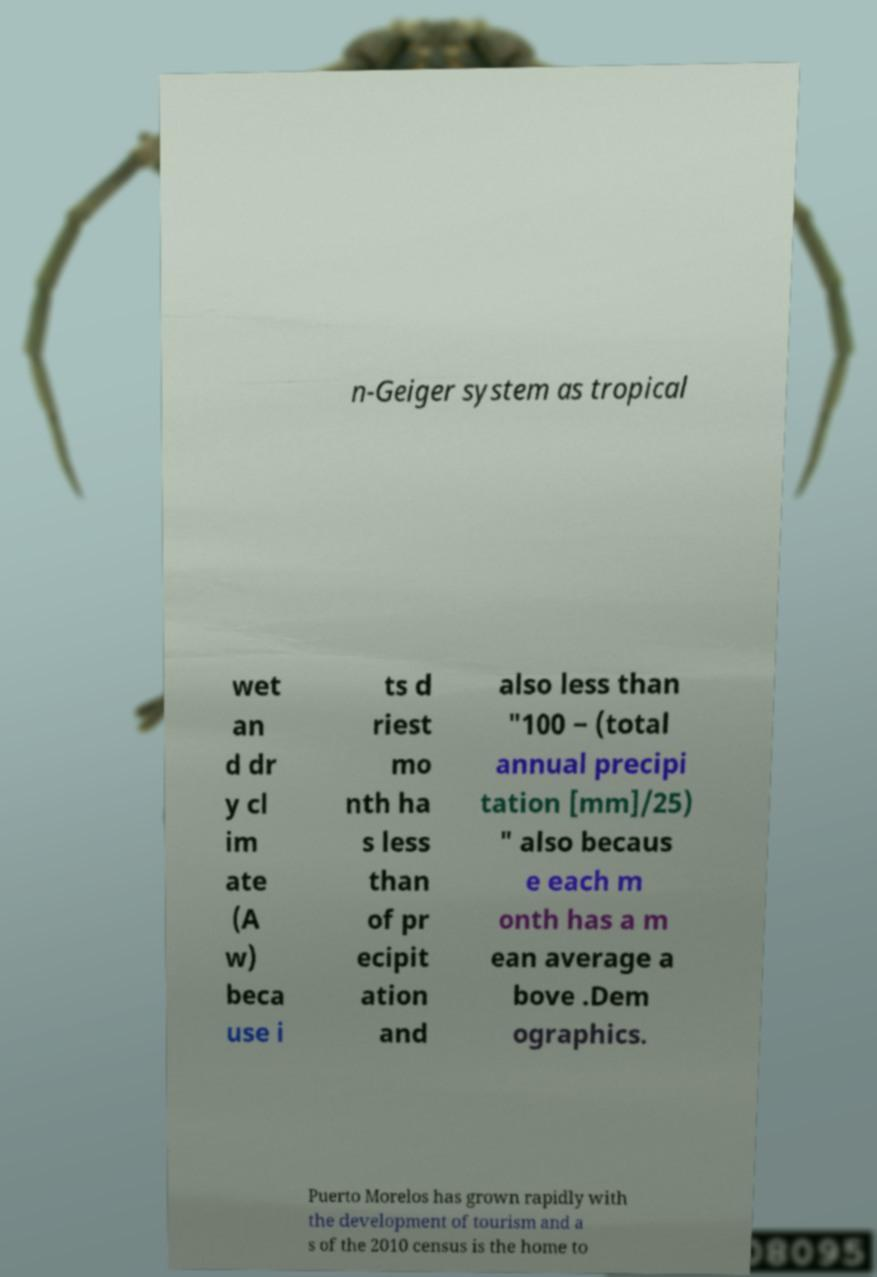Could you extract and type out the text from this image? n-Geiger system as tropical wet an d dr y cl im ate (A w) beca use i ts d riest mo nth ha s less than of pr ecipit ation and also less than "100 − (total annual precipi tation [mm]/25) " also becaus e each m onth has a m ean average a bove .Dem ographics. Puerto Morelos has grown rapidly with the development of tourism and a s of the 2010 census is the home to 